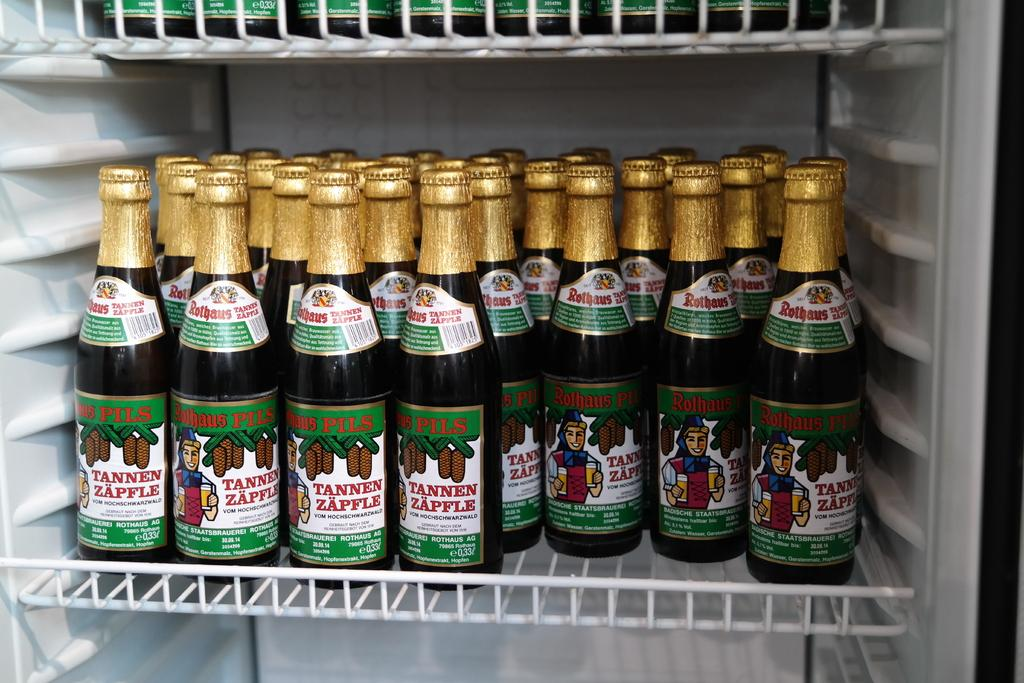<image>
Offer a succinct explanation of the picture presented. Many bottles of Tannen Zapfle Rothaus Pils are on a shelf. 